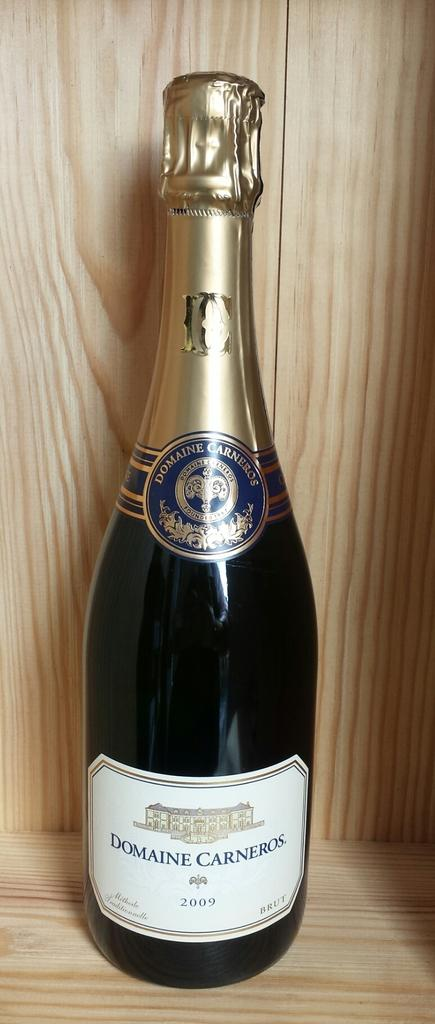<image>
Share a concise interpretation of the image provided. New bottle of Domaine Carneros sitting by itself 